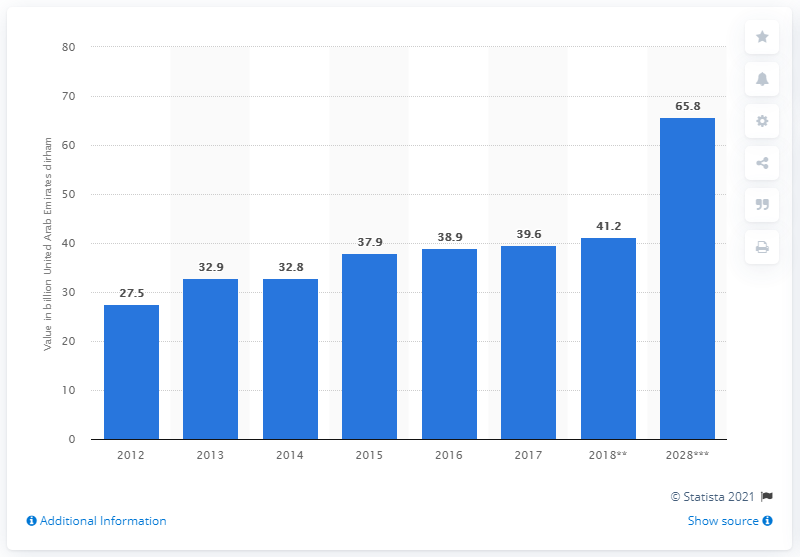List a handful of essential elements in this visual. It is estimated that by 2028, domestic expenditure will contribute approximately 65.8% of the Gross Domestic Product of the UAE. 